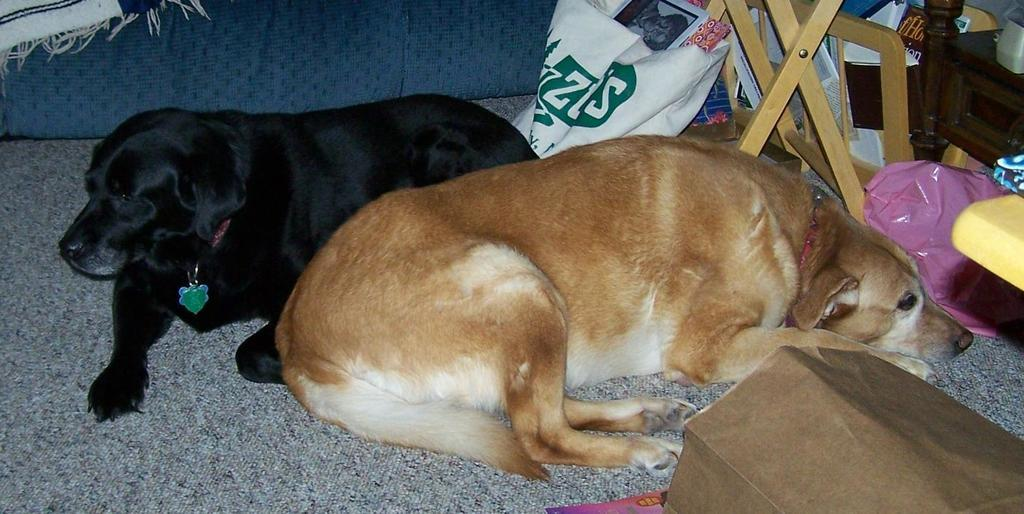What type of animals can be seen in the image? There are dogs in the image. What are the dogs doing in the image? The dogs are lying on a blanket. What can be seen in the background of the image? Polythene bags and a cupboard are present in the background. What type of fork can be seen in the image? There is no fork present in the image. Can you tell me how many goats are visible in the image? There are no goats present in the image; it features dogs lying on a blanket. 